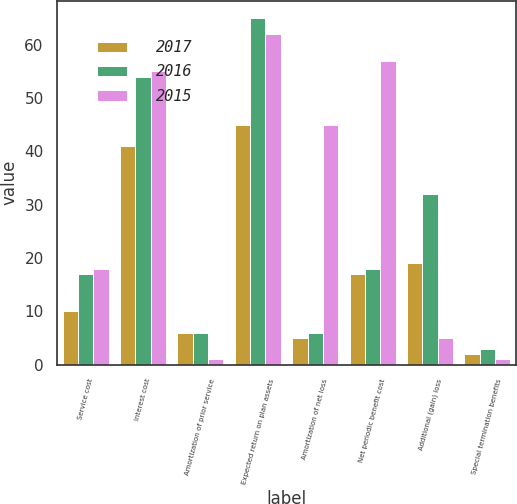<chart> <loc_0><loc_0><loc_500><loc_500><stacked_bar_chart><ecel><fcel>Service cost<fcel>Interest cost<fcel>Amortization of prior service<fcel>Expected return on plan assets<fcel>Amortization of net loss<fcel>Net periodic benefit cost<fcel>Additional (gain) loss<fcel>Special termination benefits<nl><fcel>2017<fcel>10<fcel>41<fcel>6<fcel>45<fcel>5<fcel>17<fcel>19<fcel>2<nl><fcel>2016<fcel>17<fcel>54<fcel>6<fcel>65<fcel>6<fcel>18<fcel>32<fcel>3<nl><fcel>2015<fcel>18<fcel>55<fcel>1<fcel>62<fcel>45<fcel>57<fcel>5<fcel>1<nl></chart> 